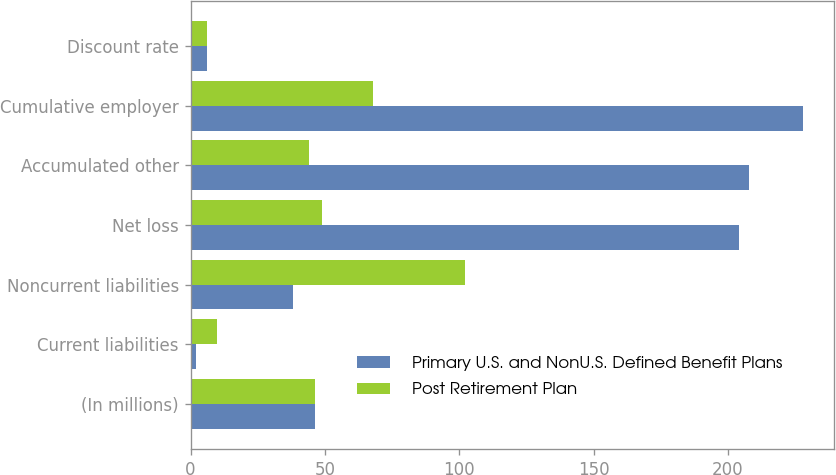Convert chart. <chart><loc_0><loc_0><loc_500><loc_500><stacked_bar_chart><ecel><fcel>(In millions)<fcel>Current liabilities<fcel>Noncurrent liabilities<fcel>Net loss<fcel>Accumulated other<fcel>Cumulative employer<fcel>Discount rate<nl><fcel>Primary U.S. and NonU.S. Defined Benefit Plans<fcel>46.5<fcel>2<fcel>38<fcel>204<fcel>208<fcel>228<fcel>6<nl><fcel>Post Retirement Plan<fcel>46.5<fcel>10<fcel>102<fcel>49<fcel>44<fcel>68<fcel>6<nl></chart> 